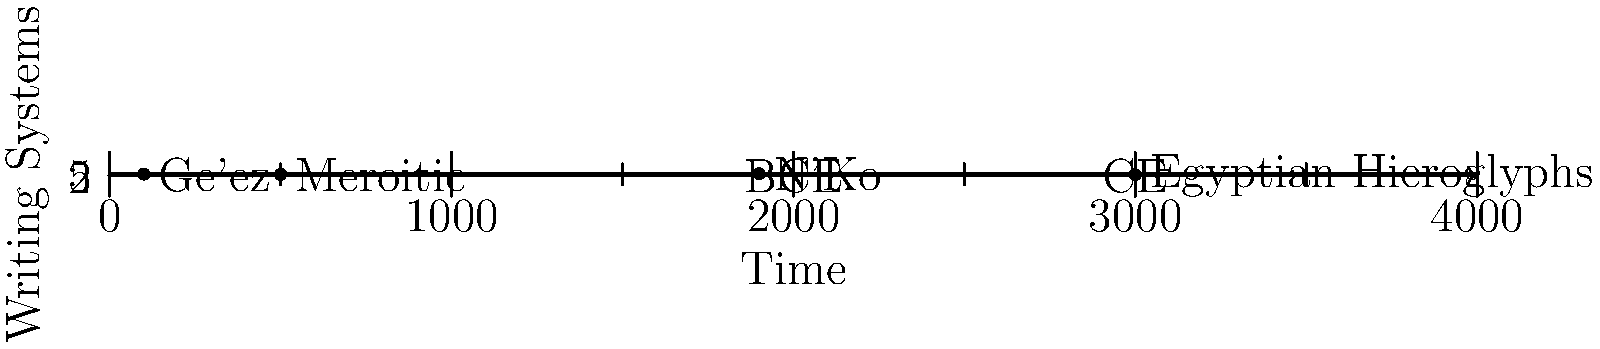Based on the timeline of African writing systems shown, which script emerged most recently, and what cultural or historical factors might have influenced its development? To answer this question, we need to analyze the timeline from left to right, considering the chronological order of the writing systems presented:

1. Egyptian Hieroglyphs: This is the oldest system shown, dating back to around 3000 BCE.
2. Meroitic: This script appears next, around 500 BCE.
3. Ge'ez: This writing system emerges around 100 CE.
4. N'Ko: This is the most recent script on the timeline, appearing around 1900 CE.

The N'Ko script is clearly the most recent, developed in the 20th century. To understand the factors that influenced its development, we need to consider the historical context:

1. Colonial legacy: N'Ko was created in 1949 by Guinean intellectual Solomana Kante as a writing system for Mande languages.
2. Cultural preservation: It was developed in response to the dominance of the Latin alphabet introduced by colonial powers.
3. Linguistic diversity: The script aimed to represent the sounds of Mande languages more accurately than the Latin alphabet.
4. Pan-African movement: N'Ko's creation coincided with growing African nationalism and the desire for cultural independence.
5. Education and literacy: The script was designed to facilitate literacy among Mande speakers and preserve their cultural knowledge.

The development of N'Ko reflects a broader trend in post-colonial Africa of reclaiming and preserving indigenous languages and cultures, while also creating tools for modern communication and education.
Answer: N'Ko (1900 CE); influenced by post-colonial cultural reclamation and linguistic preservation. 